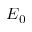<formula> <loc_0><loc_0><loc_500><loc_500>E _ { 0 }</formula> 